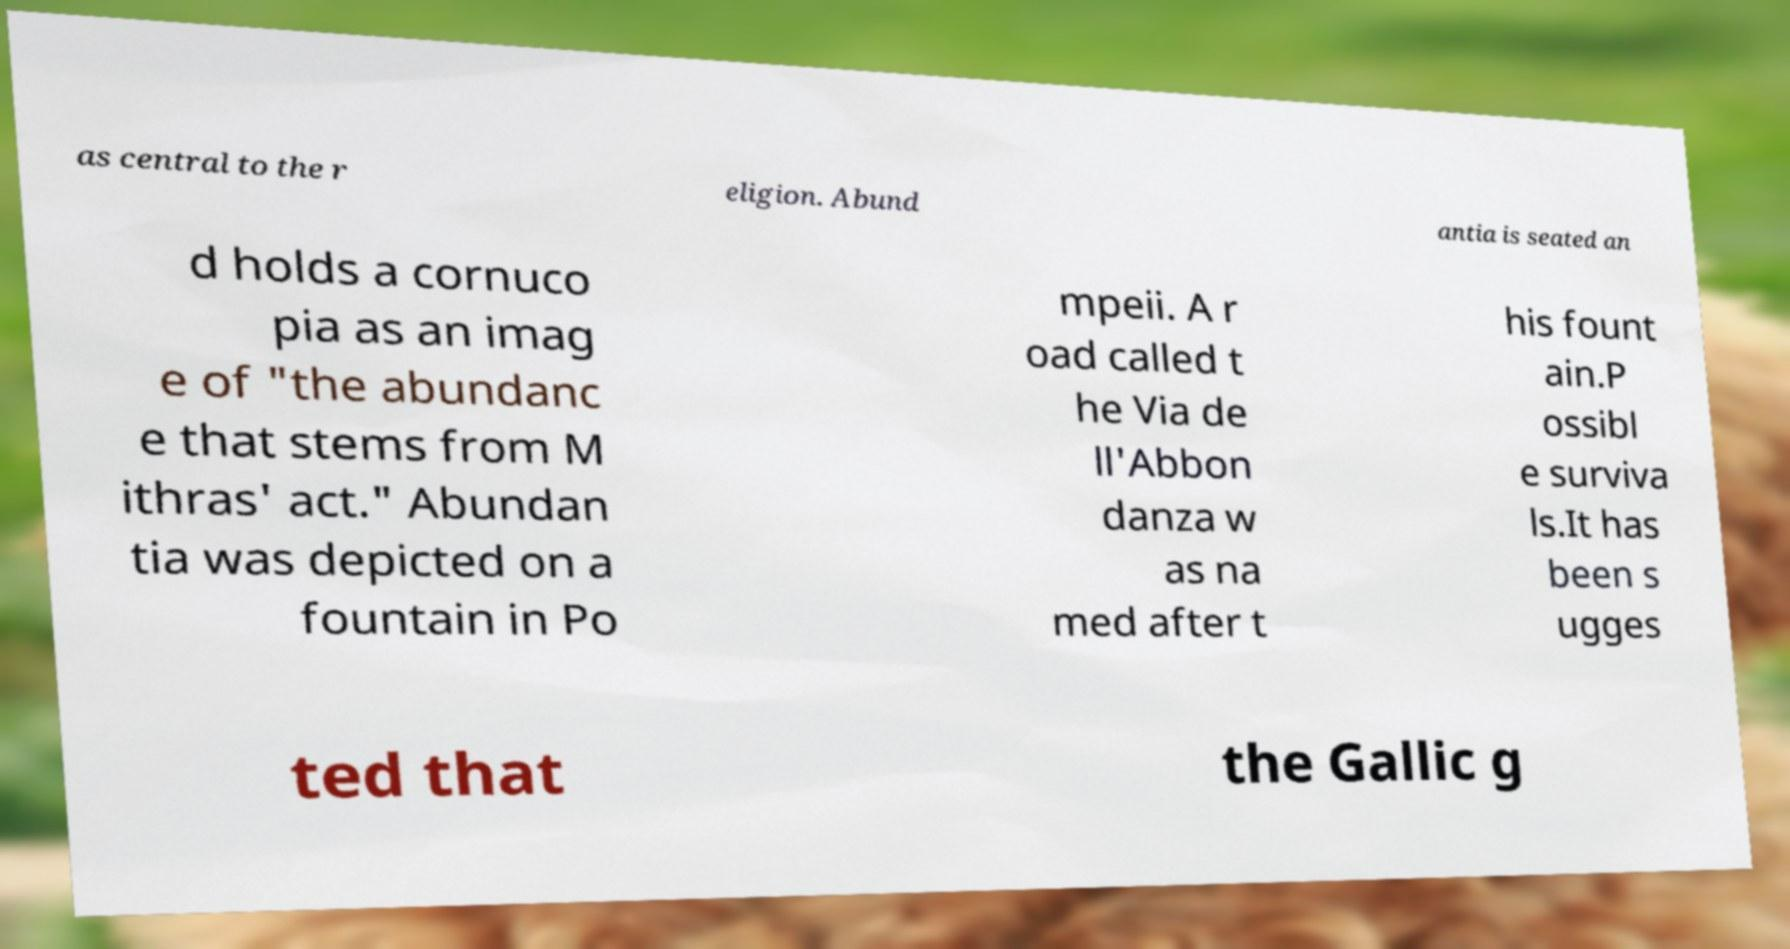What messages or text are displayed in this image? I need them in a readable, typed format. as central to the r eligion. Abund antia is seated an d holds a cornuco pia as an imag e of "the abundanc e that stems from M ithras' act." Abundan tia was depicted on a fountain in Po mpeii. A r oad called t he Via de ll'Abbon danza w as na med after t his fount ain.P ossibl e surviva ls.It has been s ugges ted that the Gallic g 